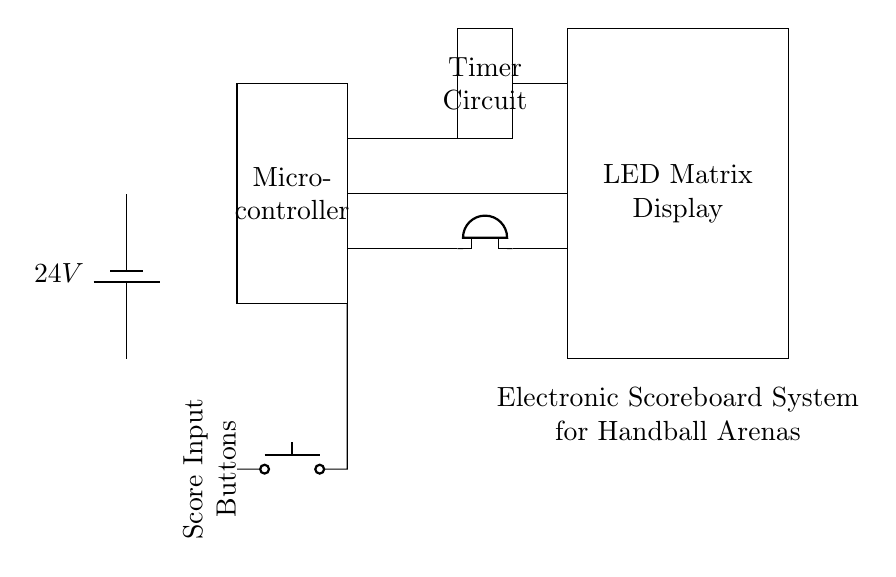What is the power supply voltage of the circuit? The circuit is powered by a battery, indicated as a 24V battery in the diagram. This voltage is crucial as it powers all components in the circuit.
Answer: 24V What component is responsible for displaying the score? The LED Matrix Display component is specifically designated in the circuit for showing the score of the game. It is a rectangular box labeled as such, highlighting its purpose in the scoreboard system.
Answer: LED Matrix Display How is the score modified in the system? The Score Input Buttons allow users to change the score. These buttons are represented and connected to the microcontroller, indicating that the input from these buttons is processed to update the score displayed.
Answer: Score Input Buttons What is the purpose of the Timer Circuit? The Timer Circuit is responsible for keeping track of the game time. It is outlined in the circuit as a rectangle, separate from other components, confirming its distinct function within the scoreboard system.
Answer: Timer Circuit Which component is used to signal alerts or notifications? The Buzzer is utilized for signaling alerts in the circuit. It is represented as a specific component and is directly connected to the Timer Circuit and LED Matrix Display, indicating its role in providing audio notifications for game events.
Answer: Buzzer How do the components communicate with each other? The connections drawn between components (lines) show how they are interconnected. The microcontroller receives inputs from the Score Input Buttons and manages outputs to the LED Matrix Display and Buzzer, illustrating a control flow in the system.
Answer: Through connections What is the main processing unit in the circuit? The Microcontroller is the main processing unit, as indicated by its labeled rectangle. It coordinates inputs from the score buttons and manages the timing and display outputs.
Answer: Microcontroller 